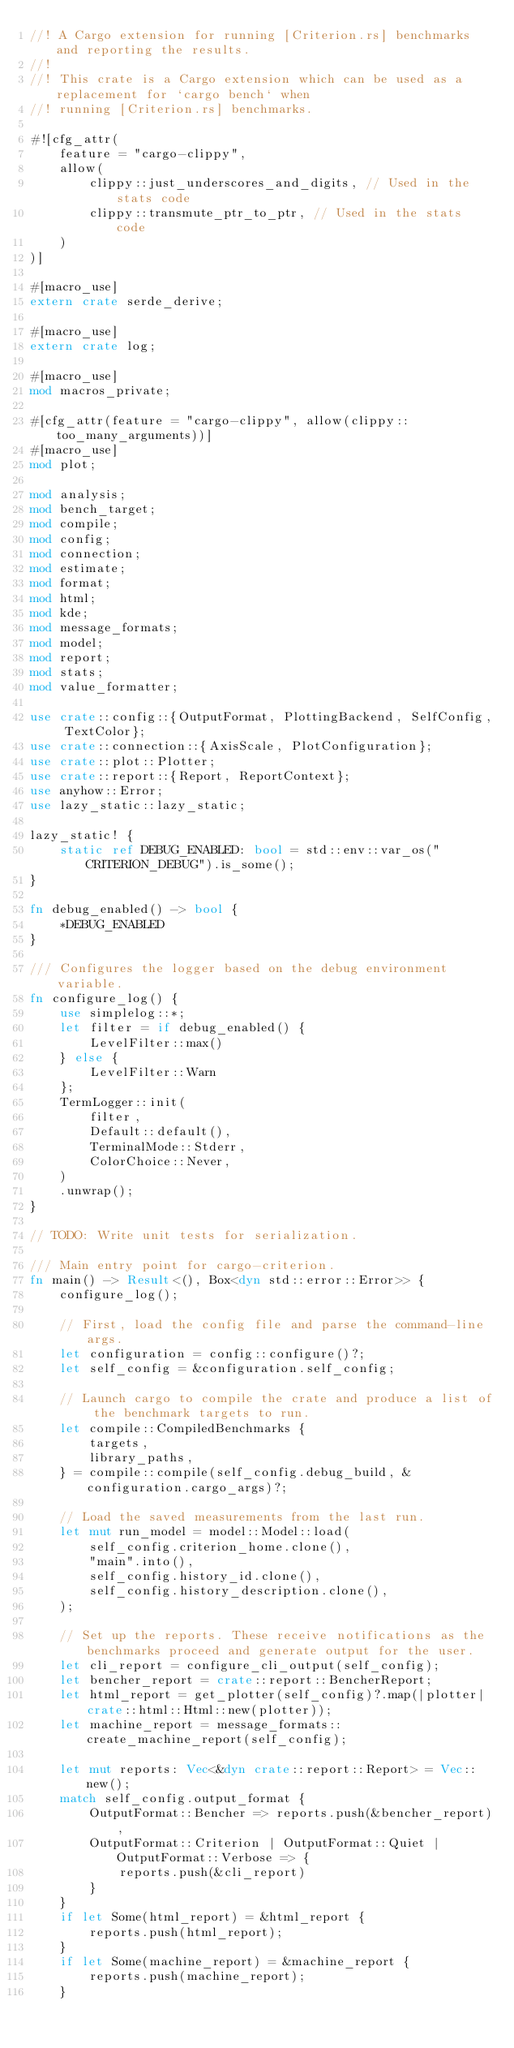Convert code to text. <code><loc_0><loc_0><loc_500><loc_500><_Rust_>//! A Cargo extension for running [Criterion.rs] benchmarks and reporting the results.
//!
//! This crate is a Cargo extension which can be used as a replacement for `cargo bench` when
//! running [Criterion.rs] benchmarks.

#![cfg_attr(
    feature = "cargo-clippy",
    allow(
        clippy::just_underscores_and_digits, // Used in the stats code
        clippy::transmute_ptr_to_ptr, // Used in the stats code
    )
)]

#[macro_use]
extern crate serde_derive;

#[macro_use]
extern crate log;

#[macro_use]
mod macros_private;

#[cfg_attr(feature = "cargo-clippy", allow(clippy::too_many_arguments))]
#[macro_use]
mod plot;

mod analysis;
mod bench_target;
mod compile;
mod config;
mod connection;
mod estimate;
mod format;
mod html;
mod kde;
mod message_formats;
mod model;
mod report;
mod stats;
mod value_formatter;

use crate::config::{OutputFormat, PlottingBackend, SelfConfig, TextColor};
use crate::connection::{AxisScale, PlotConfiguration};
use crate::plot::Plotter;
use crate::report::{Report, ReportContext};
use anyhow::Error;
use lazy_static::lazy_static;

lazy_static! {
    static ref DEBUG_ENABLED: bool = std::env::var_os("CRITERION_DEBUG").is_some();
}

fn debug_enabled() -> bool {
    *DEBUG_ENABLED
}

/// Configures the logger based on the debug environment variable.
fn configure_log() {
    use simplelog::*;
    let filter = if debug_enabled() {
        LevelFilter::max()
    } else {
        LevelFilter::Warn
    };
    TermLogger::init(
        filter,
        Default::default(),
        TerminalMode::Stderr,
        ColorChoice::Never,
    )
    .unwrap();
}

// TODO: Write unit tests for serialization.

/// Main entry point for cargo-criterion.
fn main() -> Result<(), Box<dyn std::error::Error>> {
    configure_log();

    // First, load the config file and parse the command-line args.
    let configuration = config::configure()?;
    let self_config = &configuration.self_config;

    // Launch cargo to compile the crate and produce a list of the benchmark targets to run.
    let compile::CompiledBenchmarks {
        targets,
        library_paths,
    } = compile::compile(self_config.debug_build, &configuration.cargo_args)?;

    // Load the saved measurements from the last run.
    let mut run_model = model::Model::load(
        self_config.criterion_home.clone(),
        "main".into(),
        self_config.history_id.clone(),
        self_config.history_description.clone(),
    );

    // Set up the reports. These receive notifications as the benchmarks proceed and generate output for the user.
    let cli_report = configure_cli_output(self_config);
    let bencher_report = crate::report::BencherReport;
    let html_report = get_plotter(self_config)?.map(|plotter| crate::html::Html::new(plotter));
    let machine_report = message_formats::create_machine_report(self_config);

    let mut reports: Vec<&dyn crate::report::Report> = Vec::new();
    match self_config.output_format {
        OutputFormat::Bencher => reports.push(&bencher_report),
        OutputFormat::Criterion | OutputFormat::Quiet | OutputFormat::Verbose => {
            reports.push(&cli_report)
        }
    }
    if let Some(html_report) = &html_report {
        reports.push(html_report);
    }
    if let Some(machine_report) = &machine_report {
        reports.push(machine_report);
    }</code> 